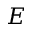<formula> <loc_0><loc_0><loc_500><loc_500>E</formula> 